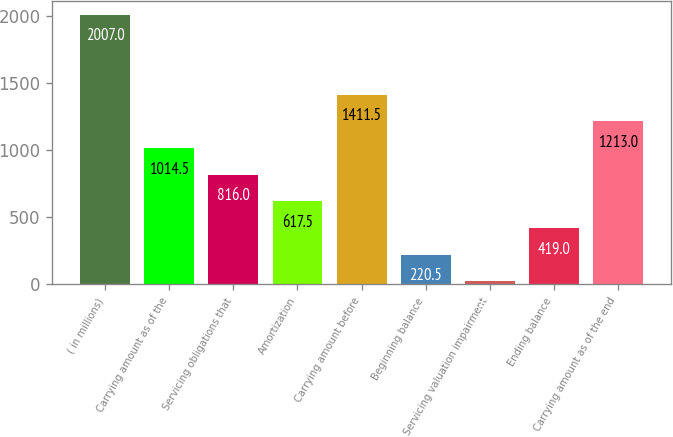Convert chart. <chart><loc_0><loc_0><loc_500><loc_500><bar_chart><fcel>( in millions)<fcel>Carrying amount as of the<fcel>Servicing obligations that<fcel>Amortization<fcel>Carrying amount before<fcel>Beginning balance<fcel>Servicing valuation impairment<fcel>Ending balance<fcel>Carrying amount as of the end<nl><fcel>2007<fcel>1014.5<fcel>816<fcel>617.5<fcel>1411.5<fcel>220.5<fcel>22<fcel>419<fcel>1213<nl></chart> 